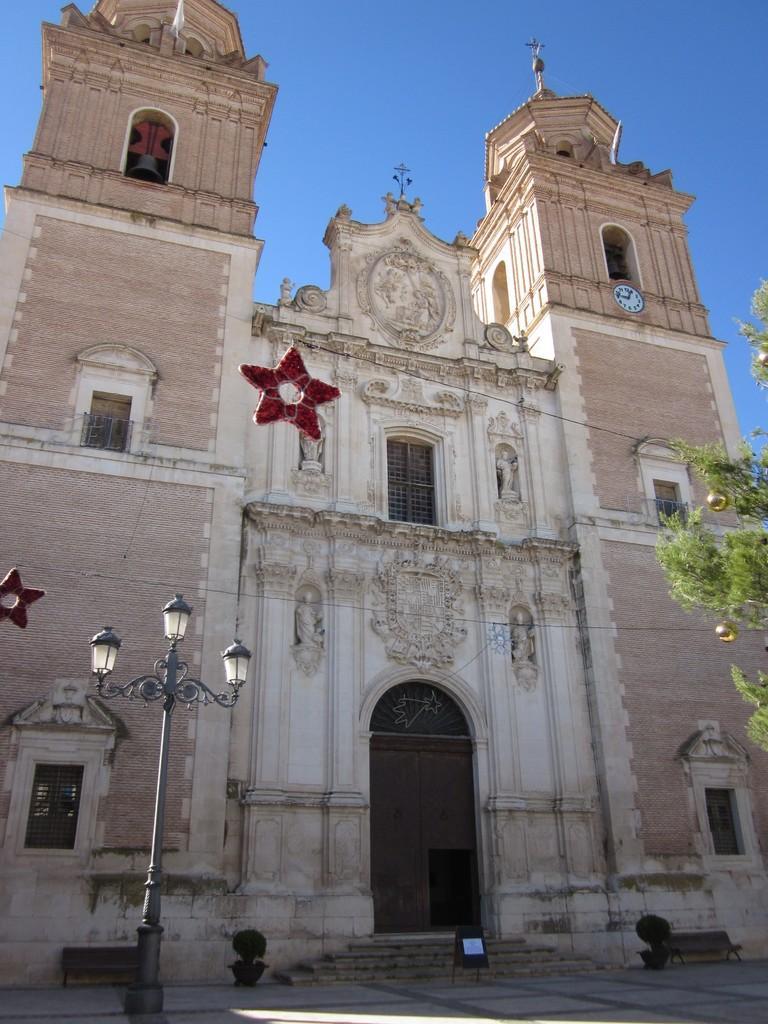Please provide a concise description of this image. In this image I see a building which is of white and light brown in color and I see the red color stars and I see a pole on which there are 3 lights and I see the golden color things on this green leaves and I see a clock over here and I can also see 2 benches and 2 plants and I see the steps over here. In the background I see the blue sky. 